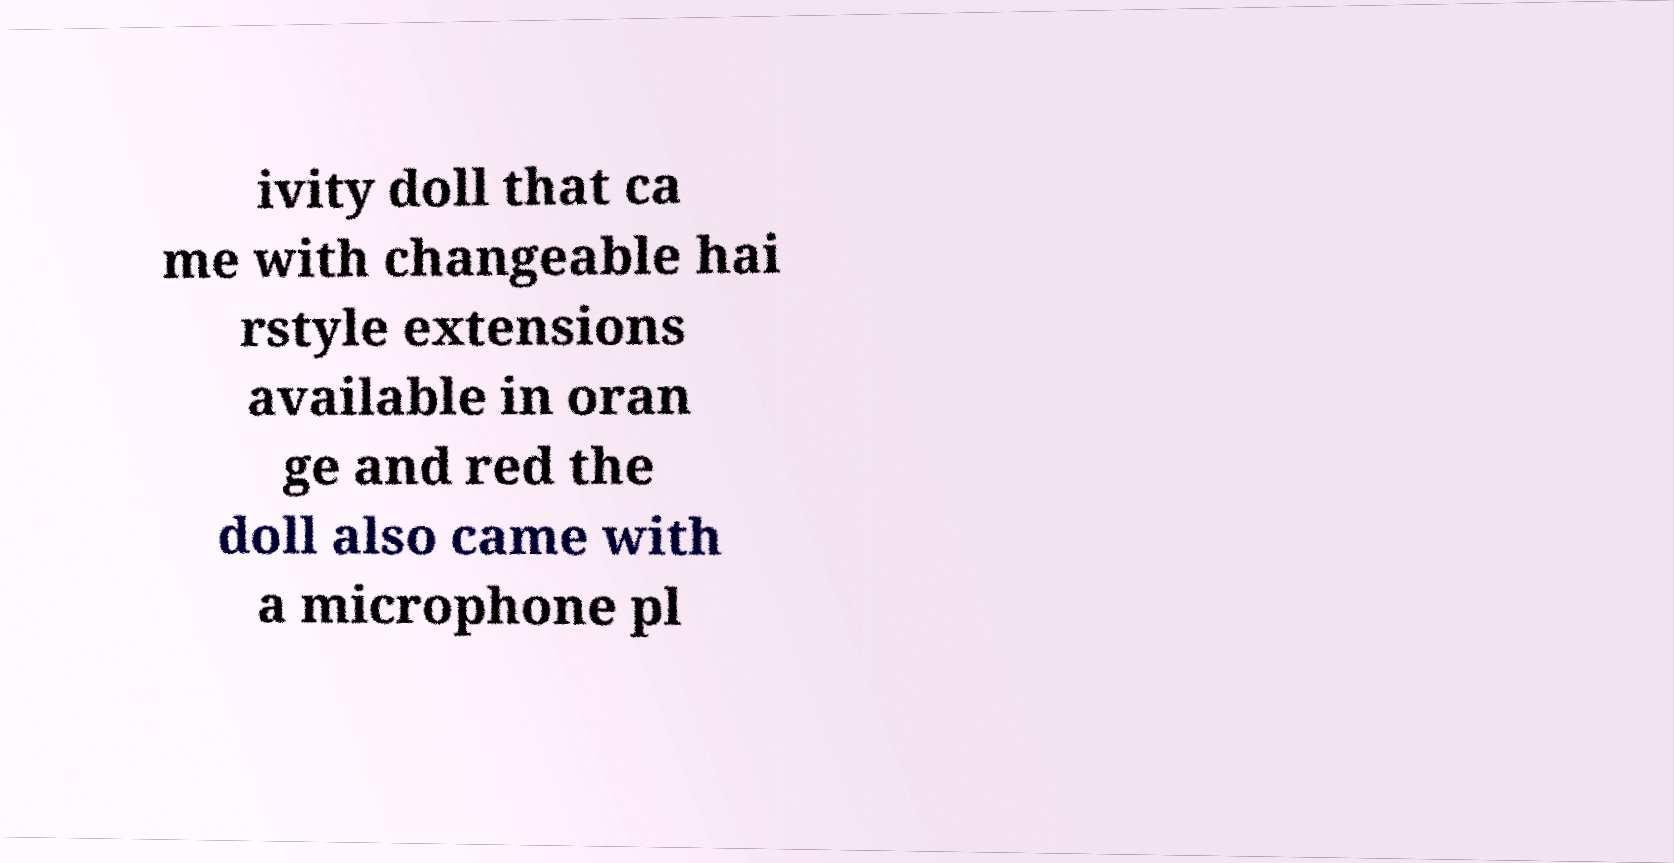What messages or text are displayed in this image? I need them in a readable, typed format. ivity doll that ca me with changeable hai rstyle extensions available in oran ge and red the doll also came with a microphone pl 